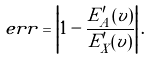Convert formula to latex. <formula><loc_0><loc_0><loc_500><loc_500>e r r = \left | 1 - \frac { E _ { A } ^ { \prime } ( v ) } { E _ { X } ^ { \prime } ( v ) } \right | .</formula> 